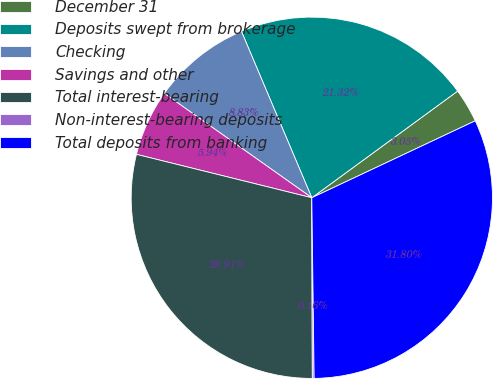Convert chart to OTSL. <chart><loc_0><loc_0><loc_500><loc_500><pie_chart><fcel>December 31<fcel>Deposits swept from brokerage<fcel>Checking<fcel>Savings and other<fcel>Total interest-bearing<fcel>Non-interest-bearing deposits<fcel>Total deposits from banking<nl><fcel>3.05%<fcel>21.32%<fcel>8.83%<fcel>5.94%<fcel>28.91%<fcel>0.16%<fcel>31.8%<nl></chart> 